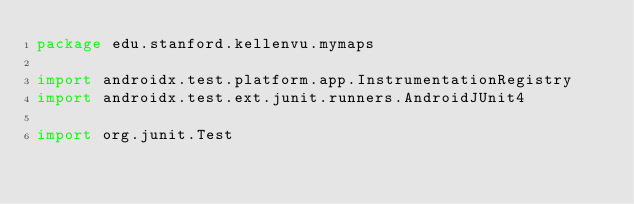<code> <loc_0><loc_0><loc_500><loc_500><_Kotlin_>package edu.stanford.kellenvu.mymaps

import androidx.test.platform.app.InstrumentationRegistry
import androidx.test.ext.junit.runners.AndroidJUnit4

import org.junit.Test</code> 